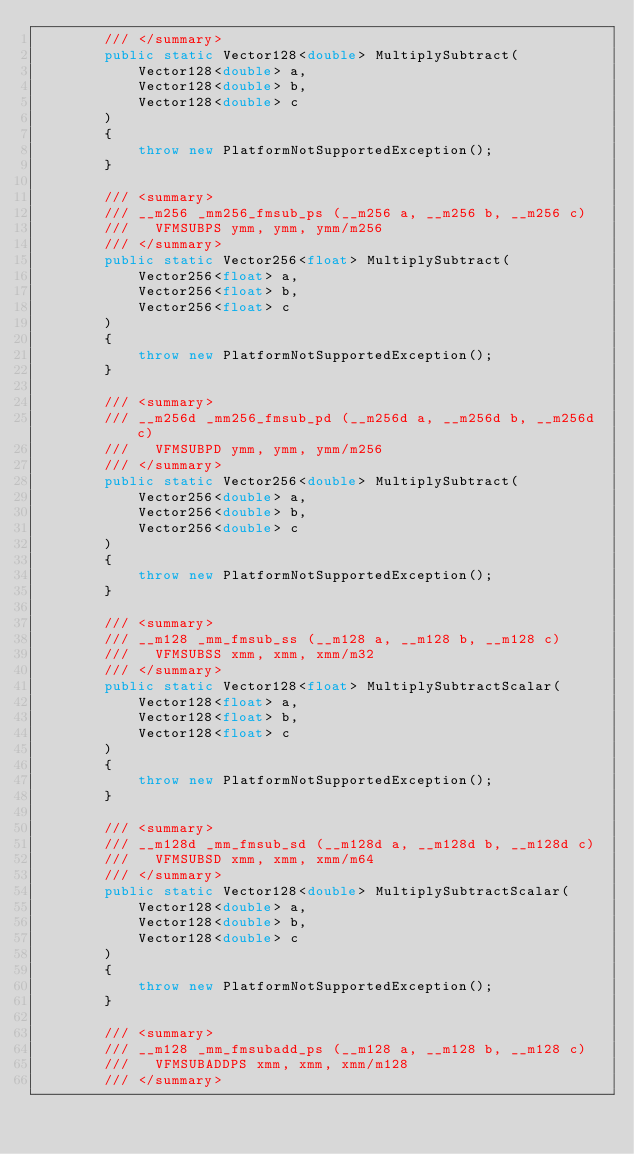Convert code to text. <code><loc_0><loc_0><loc_500><loc_500><_C#_>        /// </summary>
        public static Vector128<double> MultiplySubtract(
            Vector128<double> a,
            Vector128<double> b,
            Vector128<double> c
        )
        {
            throw new PlatformNotSupportedException();
        }

        /// <summary>
        /// __m256 _mm256_fmsub_ps (__m256 a, __m256 b, __m256 c)
        ///   VFMSUBPS ymm, ymm, ymm/m256
        /// </summary>
        public static Vector256<float> MultiplySubtract(
            Vector256<float> a,
            Vector256<float> b,
            Vector256<float> c
        )
        {
            throw new PlatformNotSupportedException();
        }

        /// <summary>
        /// __m256d _mm256_fmsub_pd (__m256d a, __m256d b, __m256d c)
        ///   VFMSUBPD ymm, ymm, ymm/m256
        /// </summary>
        public static Vector256<double> MultiplySubtract(
            Vector256<double> a,
            Vector256<double> b,
            Vector256<double> c
        )
        {
            throw new PlatformNotSupportedException();
        }

        /// <summary>
        /// __m128 _mm_fmsub_ss (__m128 a, __m128 b, __m128 c)
        ///   VFMSUBSS xmm, xmm, xmm/m32
        /// </summary>
        public static Vector128<float> MultiplySubtractScalar(
            Vector128<float> a,
            Vector128<float> b,
            Vector128<float> c
        )
        {
            throw new PlatformNotSupportedException();
        }

        /// <summary>
        /// __m128d _mm_fmsub_sd (__m128d a, __m128d b, __m128d c)
        ///   VFMSUBSD xmm, xmm, xmm/m64
        /// </summary>
        public static Vector128<double> MultiplySubtractScalar(
            Vector128<double> a,
            Vector128<double> b,
            Vector128<double> c
        )
        {
            throw new PlatformNotSupportedException();
        }

        /// <summary>
        /// __m128 _mm_fmsubadd_ps (__m128 a, __m128 b, __m128 c)
        ///   VFMSUBADDPS xmm, xmm, xmm/m128
        /// </summary></code> 